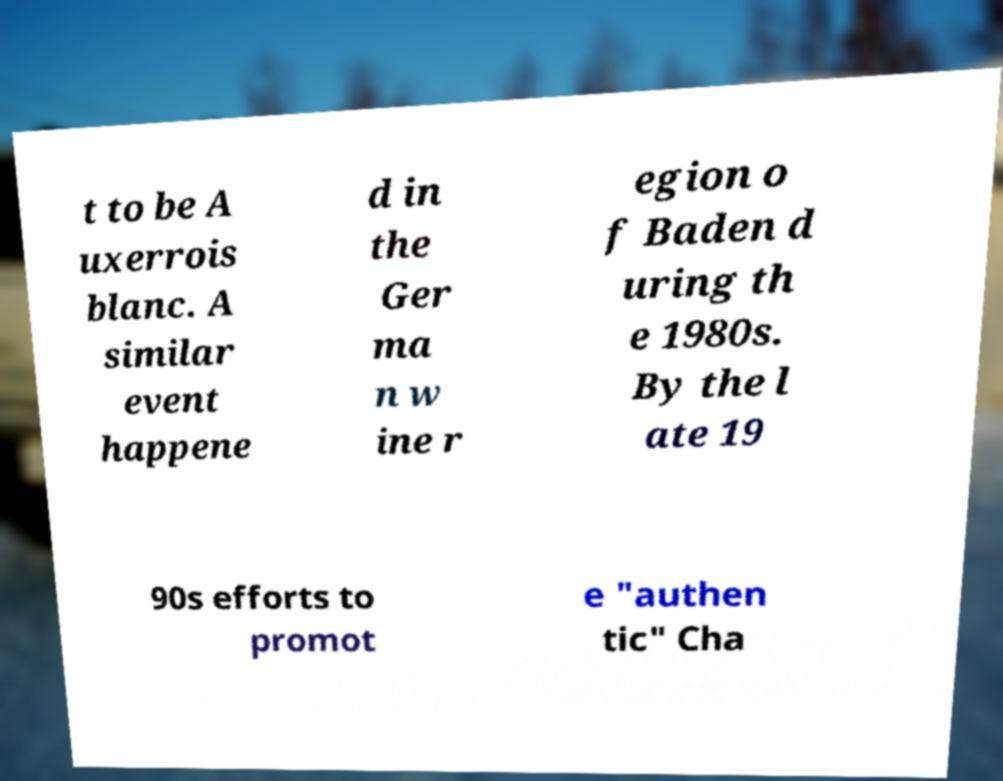There's text embedded in this image that I need extracted. Can you transcribe it verbatim? t to be A uxerrois blanc. A similar event happene d in the Ger ma n w ine r egion o f Baden d uring th e 1980s. By the l ate 19 90s efforts to promot e "authen tic" Cha 